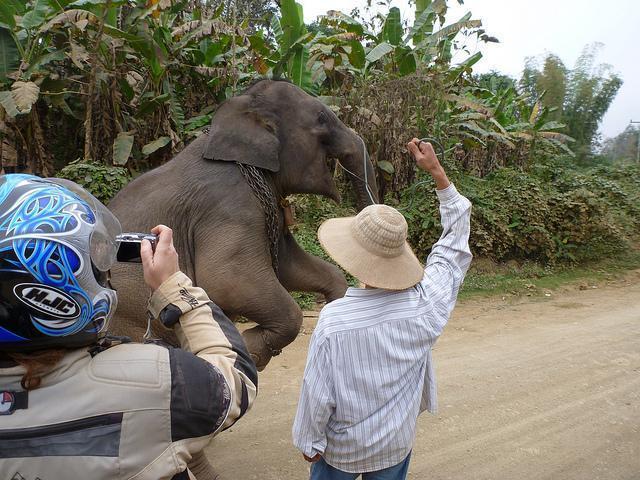How many elephants are visible?
Give a very brief answer. 1. How many people are there?
Give a very brief answer. 2. 